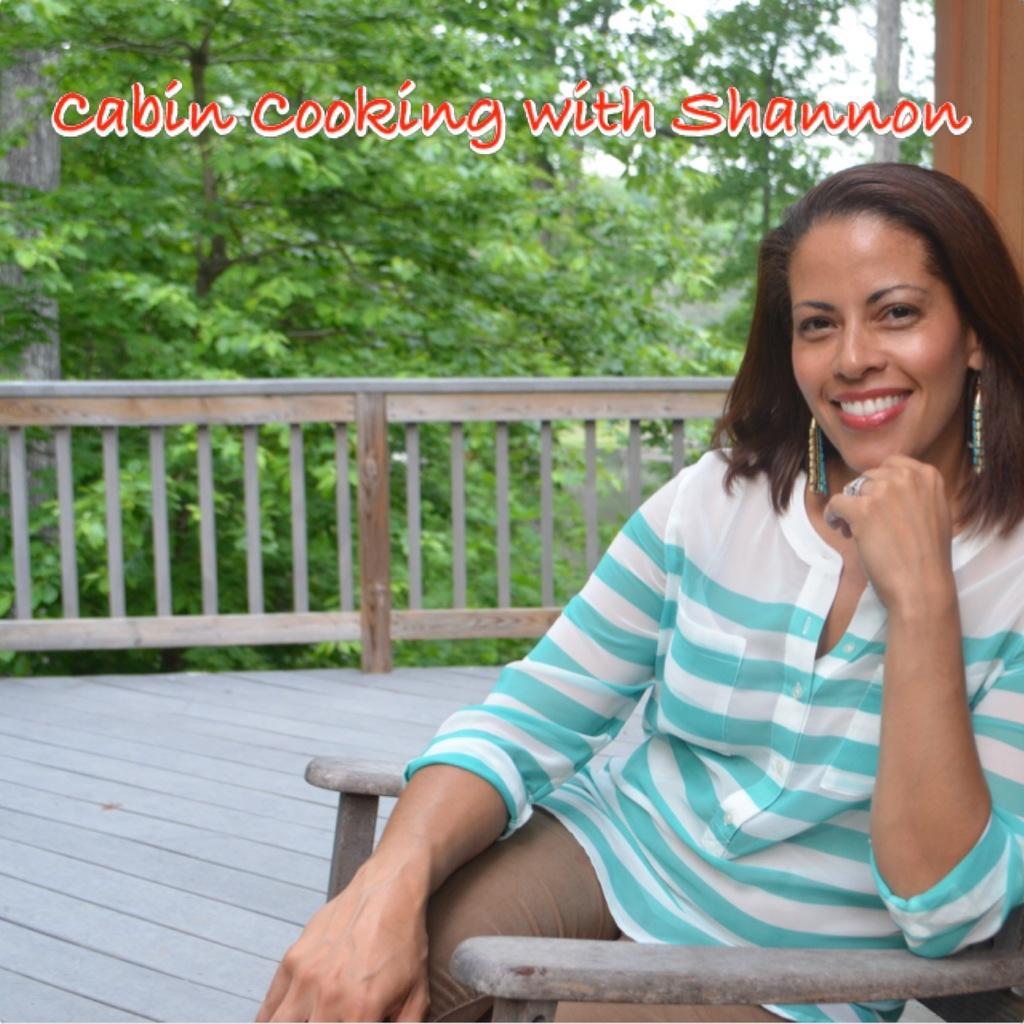Describe this image in one or two sentences. In this picture there is a woman sitting on a chair and smiling and we can see floor. At the top of the image we can see text. In the background of the image we can see fence, trees and sky. 